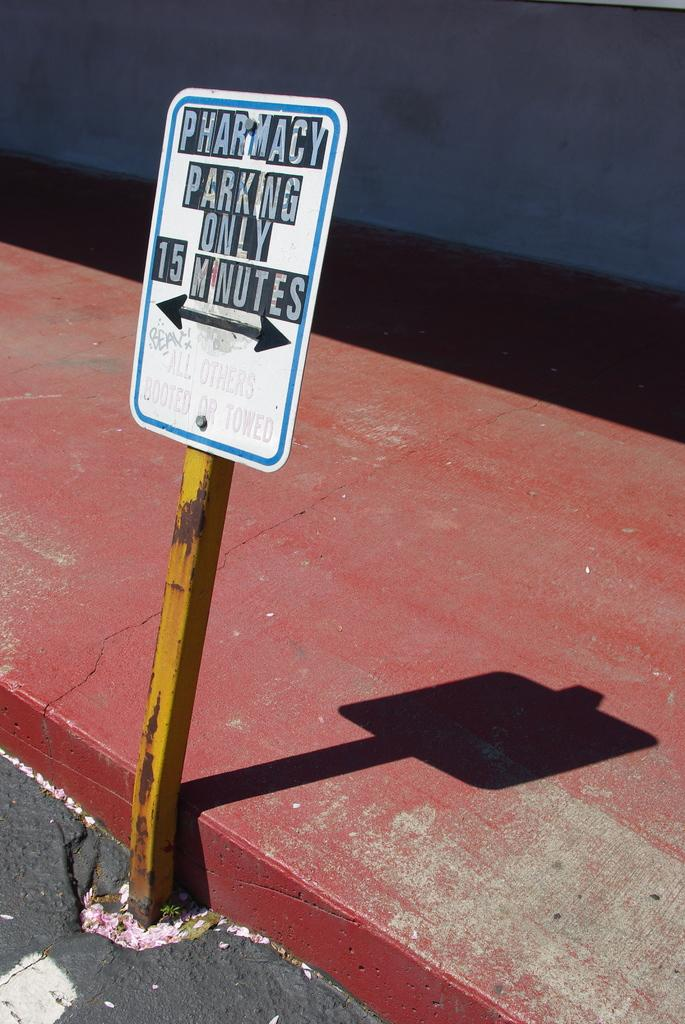<image>
Relay a brief, clear account of the picture shown. A sign shows that parking is only 15 minutes for pharmacy. 